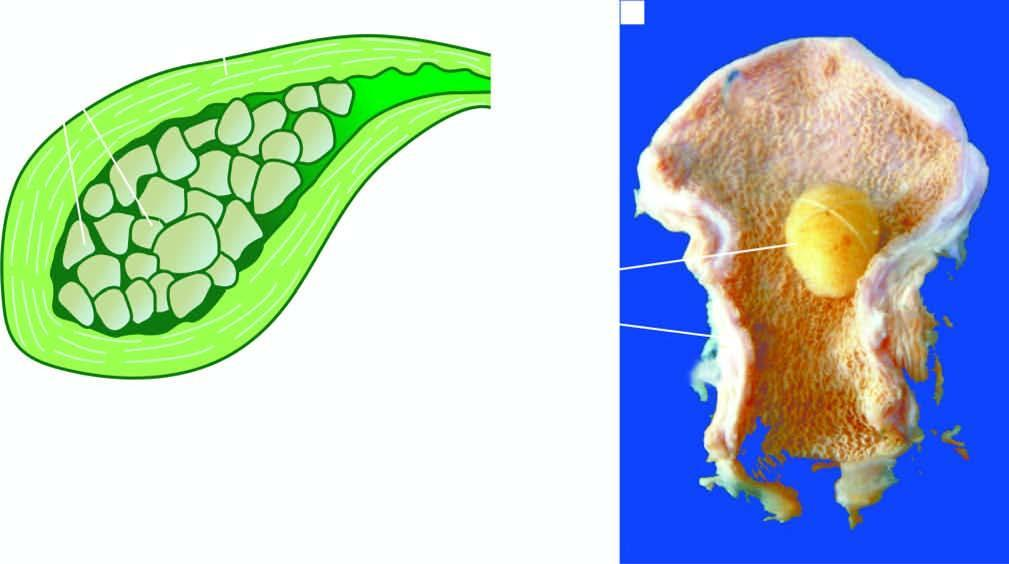what is packed with well-fitting, multiple, multi-faceted, mixed gallstones?
Answer the question using a single word or phrase. Lumen 